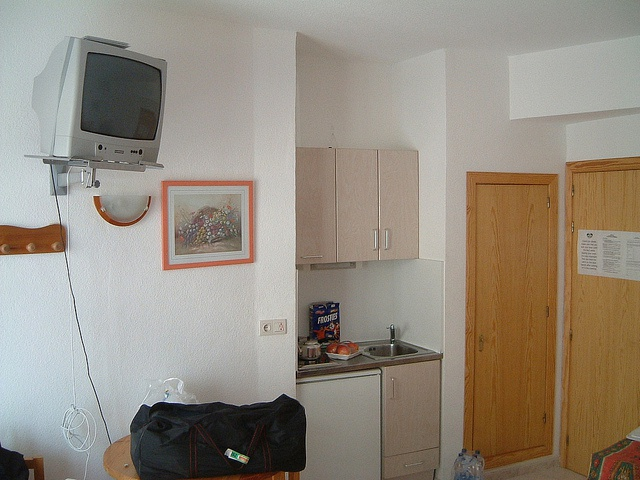Describe the objects in this image and their specific colors. I can see tv in darkgray, gray, black, and lightgray tones, handbag in darkgray, black, and gray tones, refrigerator in darkgray and gray tones, sink in darkgray, gray, and black tones, and chair in darkgray, gray, black, and maroon tones in this image. 